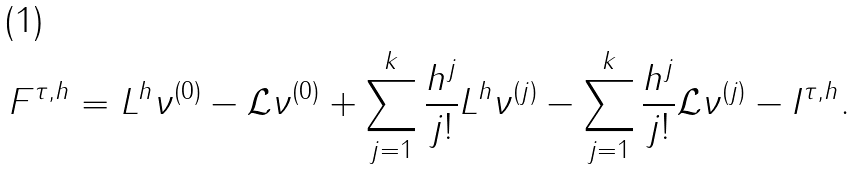Convert formula to latex. <formula><loc_0><loc_0><loc_500><loc_500>F ^ { \tau , h } = L ^ { h } \nu ^ { ( 0 ) } - \mathcal { L } \nu ^ { ( 0 ) } + \sum _ { j = 1 } ^ { k } \frac { h ^ { j } } { j ! } L ^ { h } \nu ^ { ( j ) } - \sum _ { j = 1 } ^ { k } \frac { h ^ { j } } { j ! } \mathcal { L } \nu ^ { ( j ) } - I ^ { \tau , h } .</formula> 